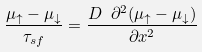<formula> <loc_0><loc_0><loc_500><loc_500>\frac { \mu _ { \uparrow } - \mu _ { \downarrow } } { \tau _ { s f } } = \frac { D \ \partial ^ { 2 } { ( \mu _ { \uparrow } - \mu _ { \downarrow } ) } } { \partial { x ^ { 2 } } }</formula> 